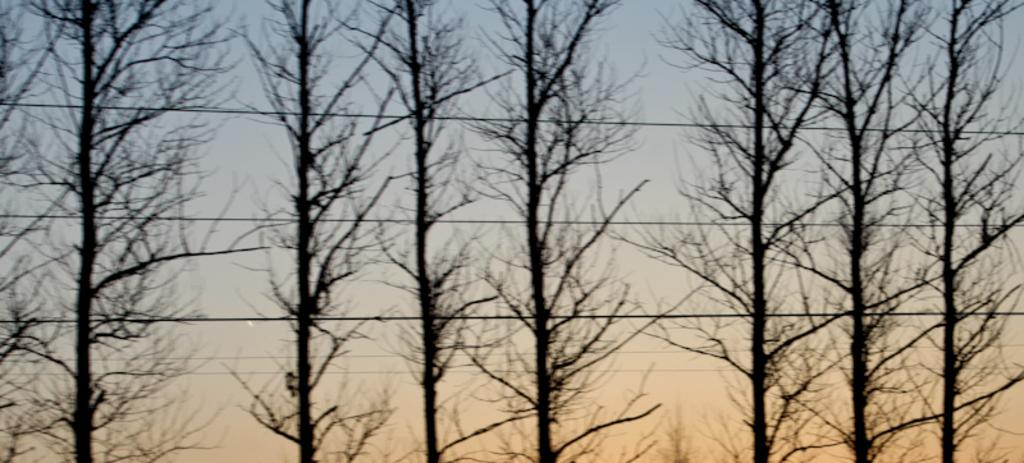What can be seen running through the image? There are cables in the image. What type of natural elements are present in the image? There are trees in the image. What can be seen in the background of the image? There are clouds and a blue sky in the background of the image. Can you hear a baby crying in the image? There is no sound in the image, so it is not possible to determine if a baby is crying or not. Is there a crib visible in the image? There is no crib present in the image. 